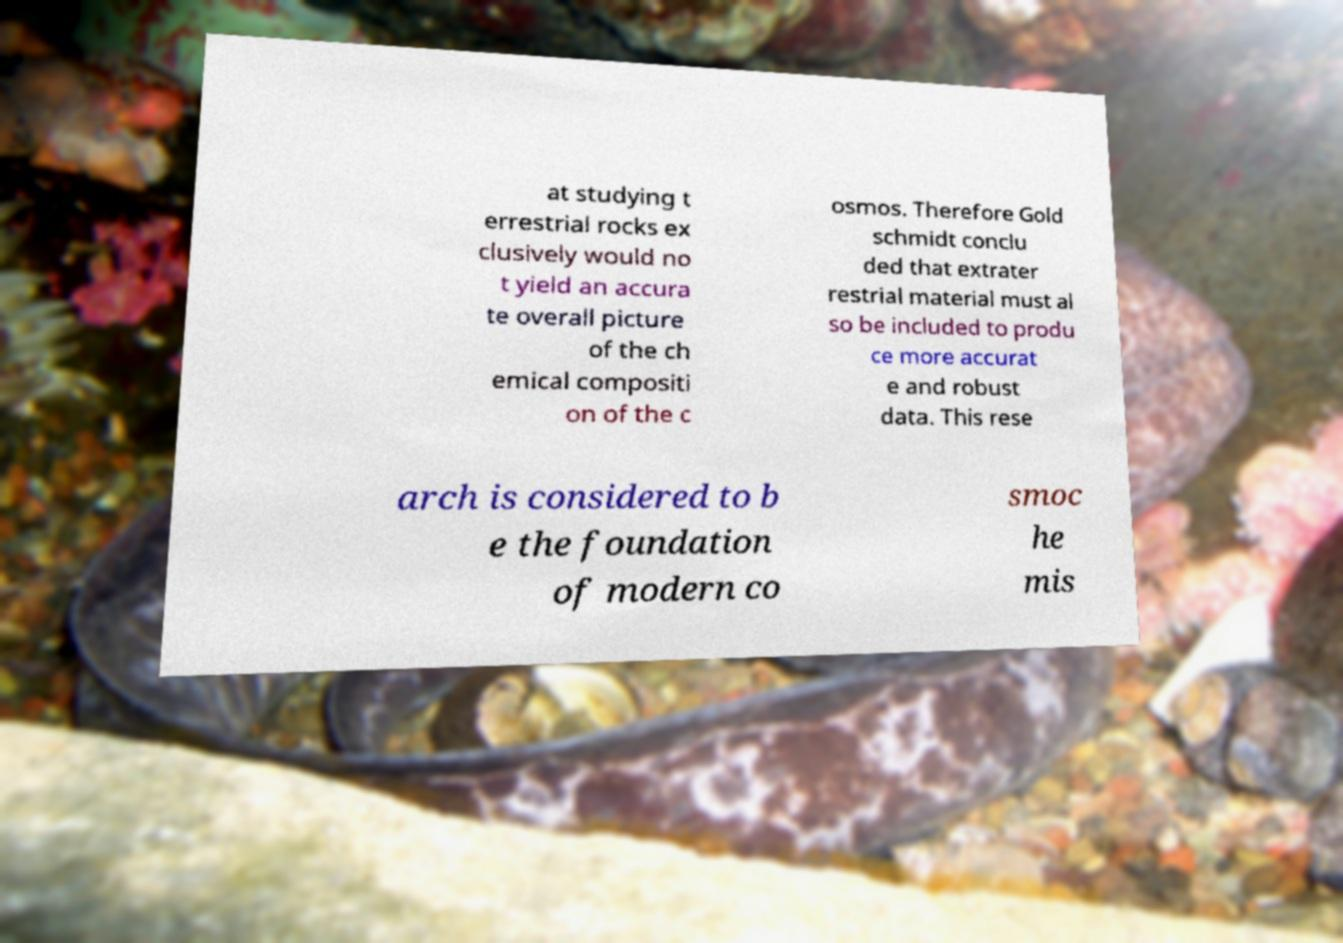I need the written content from this picture converted into text. Can you do that? at studying t errestrial rocks ex clusively would no t yield an accura te overall picture of the ch emical compositi on of the c osmos. Therefore Gold schmidt conclu ded that extrater restrial material must al so be included to produ ce more accurat e and robust data. This rese arch is considered to b e the foundation of modern co smoc he mis 